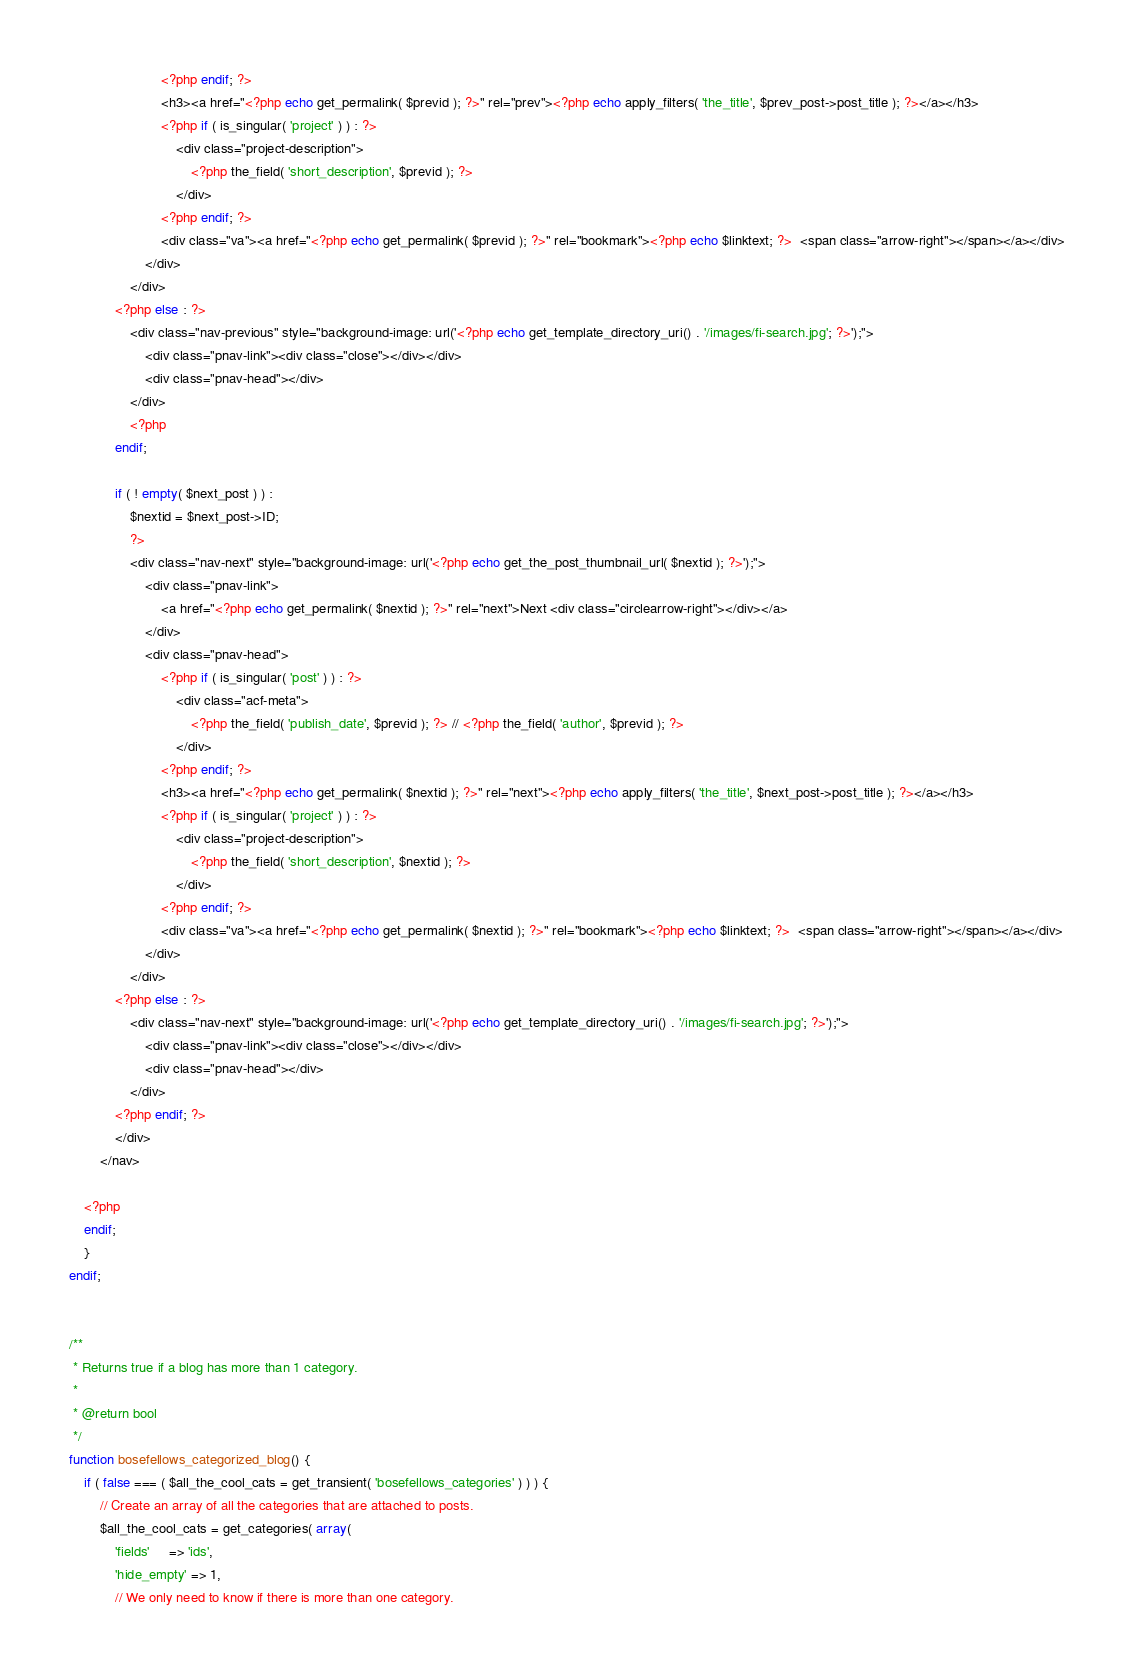Convert code to text. <code><loc_0><loc_0><loc_500><loc_500><_PHP_>						<?php endif; ?>
						<h3><a href="<?php echo get_permalink( $previd ); ?>" rel="prev"><?php echo apply_filters( 'the_title', $prev_post->post_title ); ?></a></h3>
						<?php if ( is_singular( 'project' ) ) : ?>
							<div class="project-description">
								<?php the_field( 'short_description', $previd ); ?>
							</div>
						<?php endif; ?>
						<div class="va"><a href="<?php echo get_permalink( $previd ); ?>" rel="bookmark"><?php echo $linktext; ?>  <span class="arrow-right"></span></a></div>
					</div>
				</div>
			<?php else : ?>
				<div class="nav-previous" style="background-image: url('<?php echo get_template_directory_uri() . '/images/fi-search.jpg'; ?>');">
					<div class="pnav-link"><div class="close"></div></div>
					<div class="pnav-head"></div>
				</div>
				<?php
			endif;

			if ( ! empty( $next_post ) ) :
				$nextid = $next_post->ID;
				?>
				<div class="nav-next" style="background-image: url('<?php echo get_the_post_thumbnail_url( $nextid ); ?>');">
					<div class="pnav-link">
						<a href="<?php echo get_permalink( $nextid ); ?>" rel="next">Next <div class="circlearrow-right"></div></a>
					</div>
					<div class="pnav-head">
						<?php if ( is_singular( 'post' ) ) : ?>
							<div class="acf-meta">
								<?php the_field( 'publish_date', $previd ); ?> // <?php the_field( 'author', $previd ); ?>
							</div>
						<?php endif; ?>
						<h3><a href="<?php echo get_permalink( $nextid ); ?>" rel="next"><?php echo apply_filters( 'the_title', $next_post->post_title ); ?></a></h3>
						<?php if ( is_singular( 'project' ) ) : ?>
							<div class="project-description">
								<?php the_field( 'short_description', $nextid ); ?>
							</div>
						<?php endif; ?>
						<div class="va"><a href="<?php echo get_permalink( $nextid ); ?>" rel="bookmark"><?php echo $linktext; ?>  <span class="arrow-right"></span></a></div>
					</div>
				</div>
			<?php else : ?>
				<div class="nav-next" style="background-image: url('<?php echo get_template_directory_uri() . '/images/fi-search.jpg'; ?>');">
					<div class="pnav-link"><div class="close"></div></div>
					<div class="pnav-head"></div>
				</div>
			<?php endif; ?>
			</div>
		</nav>

	<?php
	endif;
	}
endif;


/**
 * Returns true if a blog has more than 1 category.
 *
 * @return bool
 */
function bosefellows_categorized_blog() {
	if ( false === ( $all_the_cool_cats = get_transient( 'bosefellows_categories' ) ) ) {
		// Create an array of all the categories that are attached to posts.
		$all_the_cool_cats = get_categories( array(
			'fields'     => 'ids',
			'hide_empty' => 1,
			// We only need to know if there is more than one category.</code> 